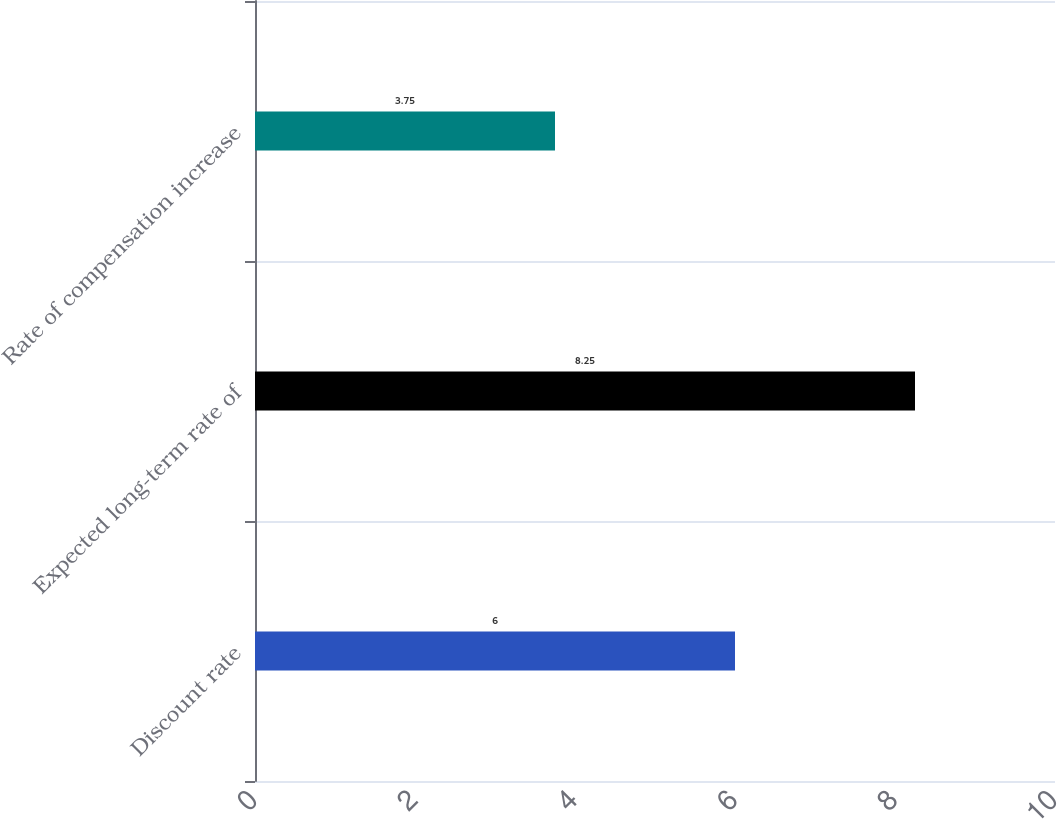Convert chart. <chart><loc_0><loc_0><loc_500><loc_500><bar_chart><fcel>Discount rate<fcel>Expected long-term rate of<fcel>Rate of compensation increase<nl><fcel>6<fcel>8.25<fcel>3.75<nl></chart> 